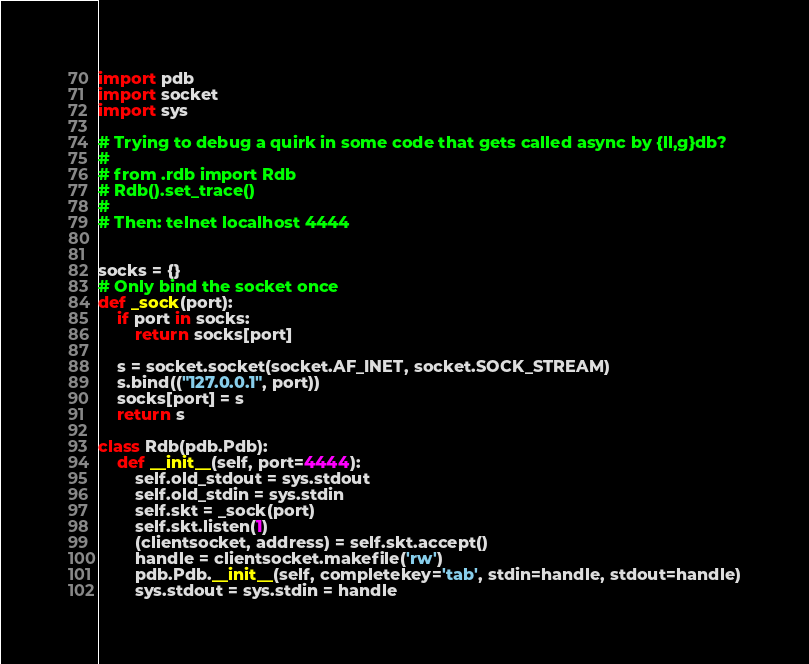<code> <loc_0><loc_0><loc_500><loc_500><_Python_>import pdb
import socket
import sys

# Trying to debug a quirk in some code that gets called async by {ll,g}db?
#
# from .rdb import Rdb
# Rdb().set_trace()
#
# Then: telnet localhost 4444


socks = {}
# Only bind the socket once
def _sock(port):
    if port in socks:
        return socks[port]

    s = socket.socket(socket.AF_INET, socket.SOCK_STREAM)
    s.bind(("127.0.0.1", port))
    socks[port] = s
    return s

class Rdb(pdb.Pdb):
    def __init__(self, port=4444):
        self.old_stdout = sys.stdout
        self.old_stdin = sys.stdin
        self.skt = _sock(port)
        self.skt.listen(1)
        (clientsocket, address) = self.skt.accept()
        handle = clientsocket.makefile('rw')
        pdb.Pdb.__init__(self, completekey='tab', stdin=handle, stdout=handle)
        sys.stdout = sys.stdin = handle
</code> 